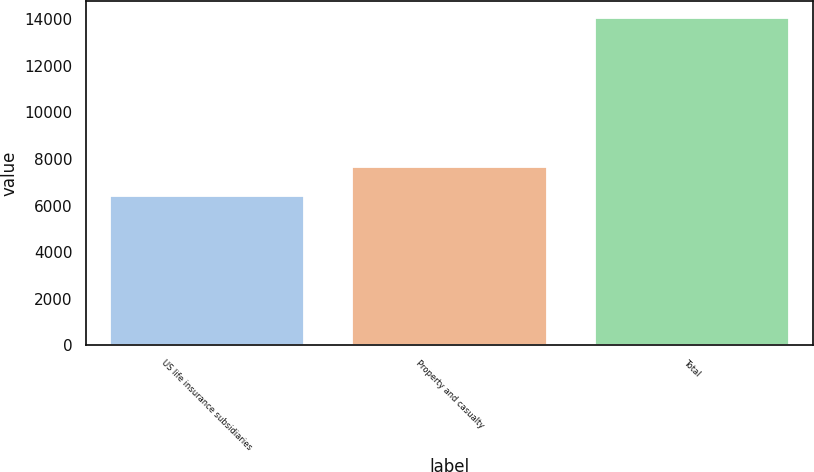Convert chart to OTSL. <chart><loc_0><loc_0><loc_500><loc_500><bar_chart><fcel>US life insurance subsidiaries<fcel>Property and casualty<fcel>Total<nl><fcel>6410<fcel>7645<fcel>14055<nl></chart> 